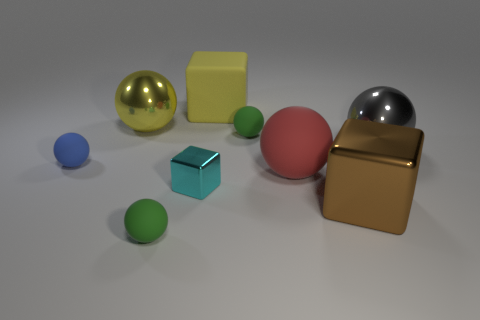Could you describe the lighting in the scene? The scene seems to be lit by a single, wide overhead light source, which creates soft shadows on the ground beneath each object. There's a subtle reflection on the shiny spheres and a diffuse reflection on the matte surfaces, suggesting a controlled indoor lighting environment, possibly evoking a studio setting. 